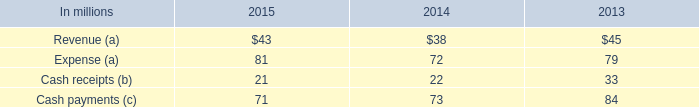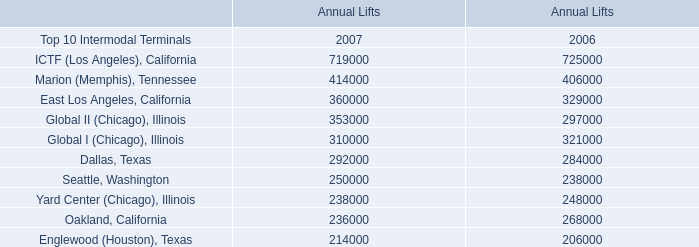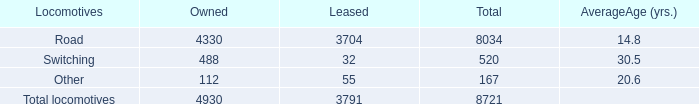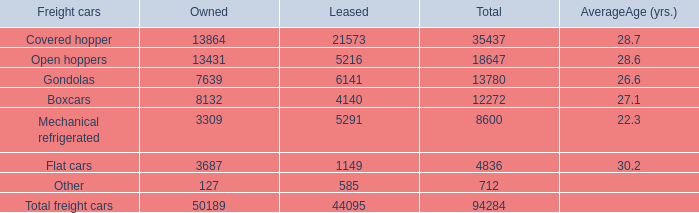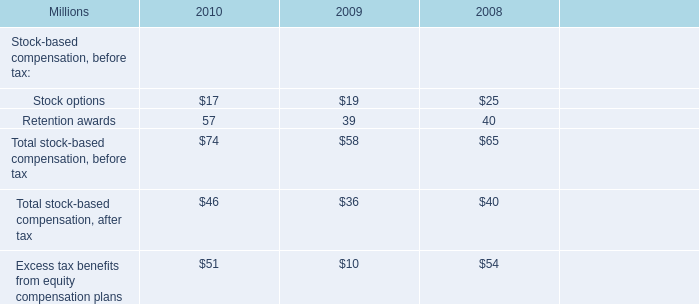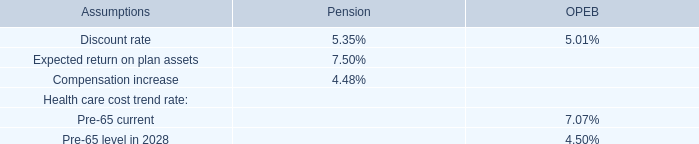What is the ratio of all Locomotives that are smaller than 100 to the sum of Locomotives, in leases? 
Computations: ((32 + 55) / ((32 + 55) + 3704))
Answer: 0.02295. 